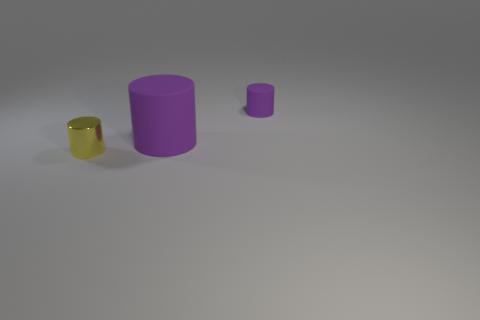Add 1 small yellow things. How many objects exist? 4 Subtract 0 brown cubes. How many objects are left? 3 Subtract all tiny metallic cylinders. Subtract all tiny yellow things. How many objects are left? 1 Add 2 matte objects. How many matte objects are left? 4 Add 1 yellow shiny things. How many yellow shiny things exist? 2 